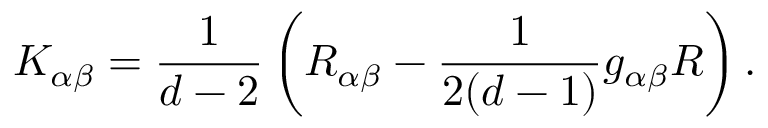Convert formula to latex. <formula><loc_0><loc_0><loc_500><loc_500>K _ { \alpha \beta } = \frac { 1 } { d - 2 } \, \left ( R _ { \alpha \beta } - \frac { 1 } { 2 ( d - 1 ) } g _ { \alpha \beta } R \right ) \, .</formula> 